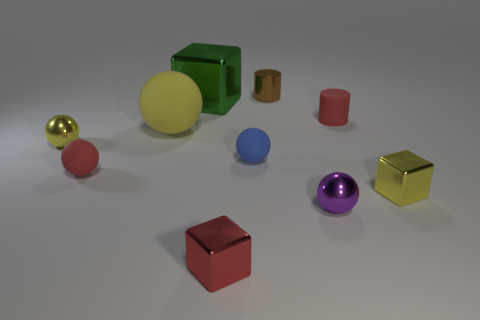Can you tell me the number of objects that are larger than the small red cube? There are six objects larger than the small red cube in the image. 